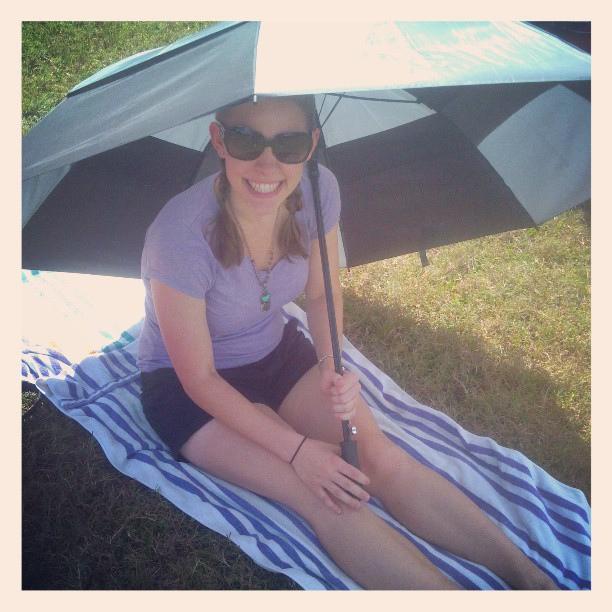Is "The umbrella is over the person." an appropriate description for the image?
Answer yes or no. Yes. 